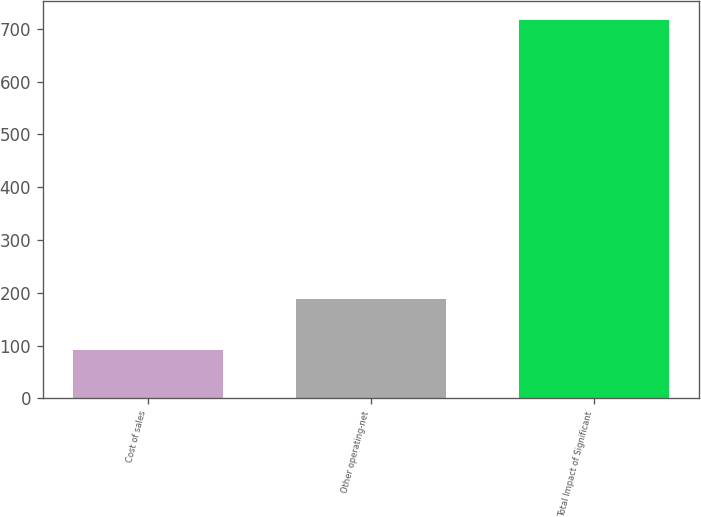Convert chart. <chart><loc_0><loc_0><loc_500><loc_500><bar_chart><fcel>Cost of sales<fcel>Other operating-net<fcel>Total Impact of Significant<nl><fcel>92<fcel>189<fcel>716<nl></chart> 